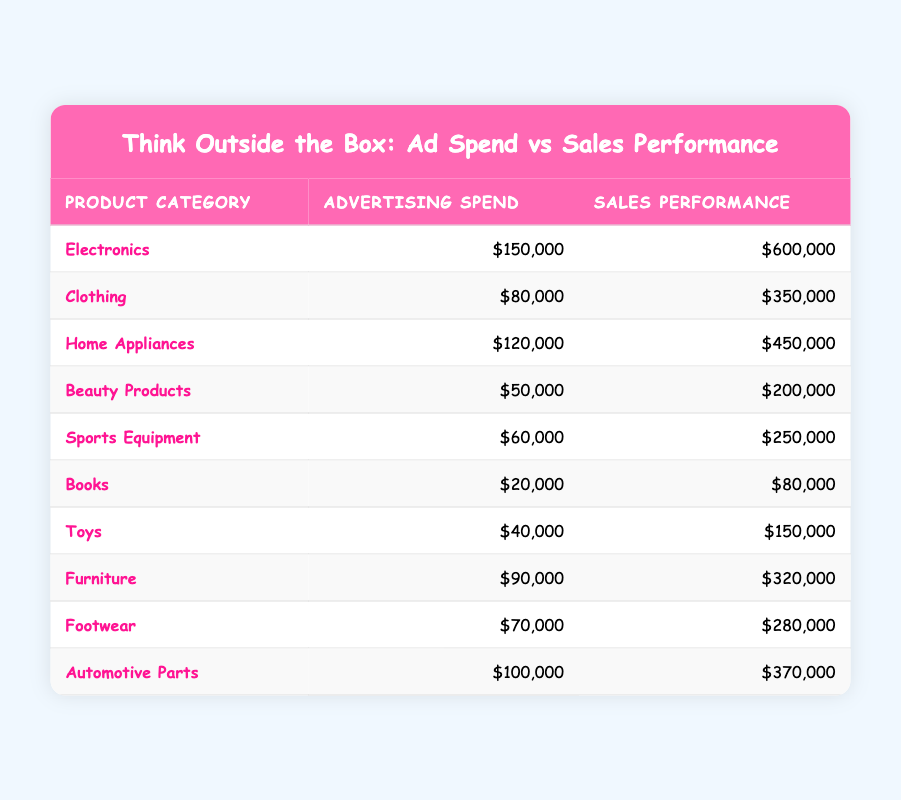What is the highest Sales Performance recorded among the product categories? The highest Sales Performance can be found by looking through the "Sales Performance" column. The values are: 600000 (Electronics), 350000 (Clothing), 450000 (Home Appliances), 200000 (Beauty Products), 250000 (Sports Equipment), 80000 (Books), 150000 (Toys), 320000 (Furniture), 280000 (Footwear), and 370000 (Automotive Parts). The maximum value among these is 600000 for the Electronics category.
Answer: 600000 Which product category had the lowest Advertising Spend? By examining the "Advertising Spend" column, the values are: 150000 (Electronics), 80000 (Clothing), 120000 (Home Appliances), 50000 (Beauty Products), 60000 (Sports Equipment), 20000 (Books), 40000 (Toys), 90000 (Furniture), 70000 (Footwear), and 100000 (Automotive Parts). The minimum value among these is 20000 for the Books category.
Answer: Books What is the average Advertising Spend for all product categories listed? To find the average Advertising Spend, first sum all values from the column: 150000 + 80000 + 120000 + 50000 + 60000 + 20000 + 40000 + 90000 + 70000 + 100000 = 680000. There are 10 categories, so divide the total by 10, which gives us 680000/10 = 68000.
Answer: 68000 Is there a product category where the Sales Performance is higher than the Advertising Spend? Checking each row, we see that: Electronics (600000 > 150000), Clothing (350000 > 80000), Home Appliances (450000 > 120000), Beauty Products (200000 > 50000), Sports Equipment (250000 > 60000), Books (80000 > 20000), Toys (150000 > 40000), Furniture (320000 > 90000), Footwear (280000 > 70000), and Automotive Parts (370000 > 100000). All categories have higher Sales Performance than Advertising Spend, so the answer is yes.
Answer: Yes What is the difference between the Advertising Spend of the highest and lowest categories? The highest Advertising Spend is 150000 (Electronics) and the lowest is 20000 (Books). To find the difference, we subtract the lowest from the highest: 150000 - 20000 = 130000.
Answer: 130000 